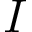<formula> <loc_0><loc_0><loc_500><loc_500>I</formula> 